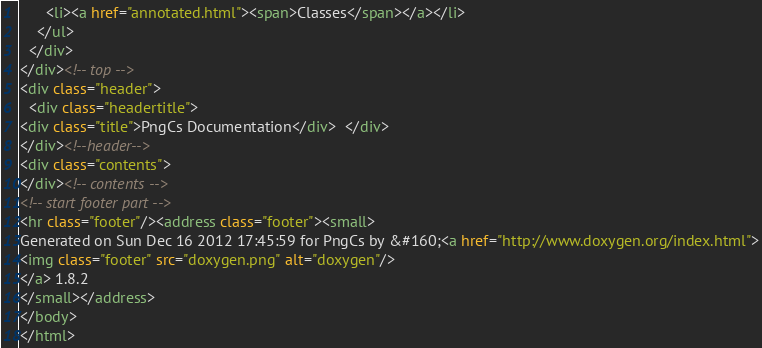<code> <loc_0><loc_0><loc_500><loc_500><_HTML_>      <li><a href="annotated.html"><span>Classes</span></a></li>
    </ul>
  </div>
</div><!-- top -->
<div class="header">
  <div class="headertitle">
<div class="title">PngCs Documentation</div>  </div>
</div><!--header-->
<div class="contents">
</div><!-- contents -->
<!-- start footer part -->
<hr class="footer"/><address class="footer"><small>
Generated on Sun Dec 16 2012 17:45:59 for PngCs by &#160;<a href="http://www.doxygen.org/index.html">
<img class="footer" src="doxygen.png" alt="doxygen"/>
</a> 1.8.2
</small></address>
</body>
</html>
</code> 